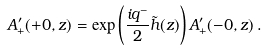<formula> <loc_0><loc_0><loc_500><loc_500>A ^ { \prime } _ { + } ( + 0 , z ) = \exp \left ( \frac { i q ^ { - } } { 2 } \tilde { h } ( z ) \right ) A ^ { \prime } _ { + } ( - 0 , z ) \, .</formula> 